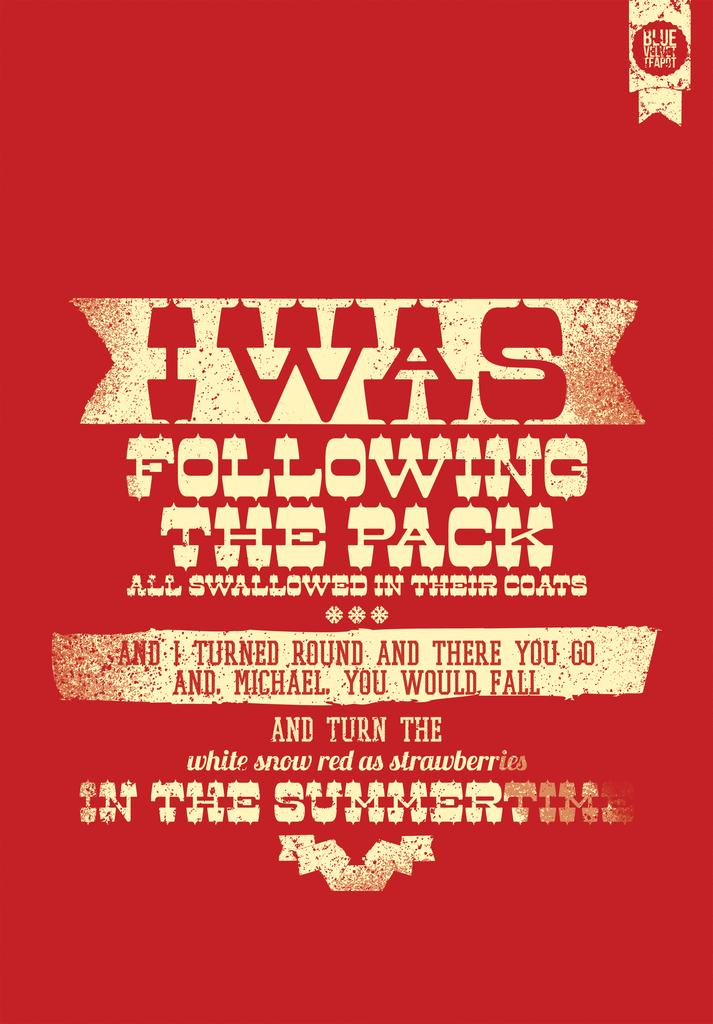<image>
Give a short and clear explanation of the subsequent image. A poster for the Blue Velvet Teapot written in Old West style writing. 